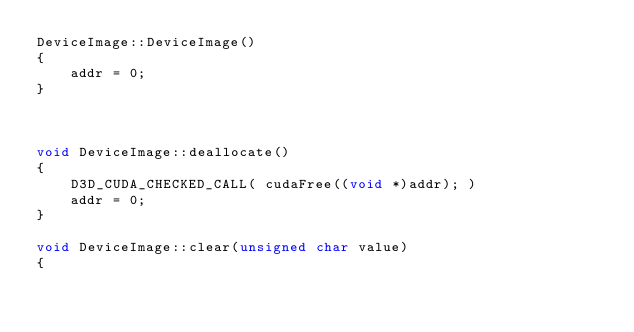<code> <loc_0><loc_0><loc_500><loc_500><_Cuda_>DeviceImage::DeviceImage()
{
    addr = 0;
}



void DeviceImage::deallocate()
{
    D3D_CUDA_CHECKED_CALL( cudaFree((void *)addr); )
    addr = 0;
}

void DeviceImage::clear(unsigned char value)
{
</code> 